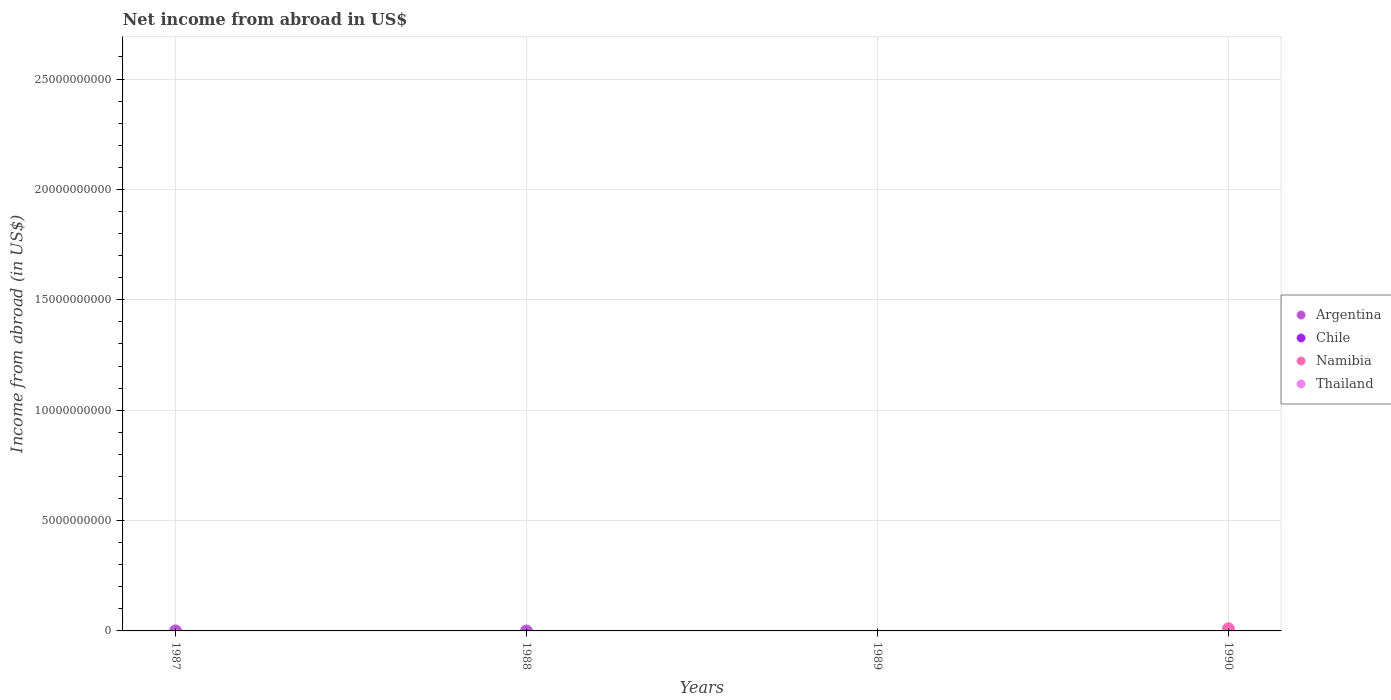Is the number of dotlines equal to the number of legend labels?
Make the answer very short. No. Across all years, what is the maximum net income from abroad in Namibia?
Make the answer very short. 9.70e+07. What is the total net income from abroad in Namibia in the graph?
Make the answer very short. 9.70e+07. Is it the case that in every year, the sum of the net income from abroad in Argentina and net income from abroad in Namibia  is greater than the net income from abroad in Chile?
Your answer should be compact. No. How many dotlines are there?
Keep it short and to the point. 1. What is the difference between two consecutive major ticks on the Y-axis?
Your response must be concise. 5.00e+09. Are the values on the major ticks of Y-axis written in scientific E-notation?
Your response must be concise. No. Does the graph contain any zero values?
Offer a terse response. Yes. What is the title of the graph?
Your response must be concise. Net income from abroad in US$. Does "Central African Republic" appear as one of the legend labels in the graph?
Make the answer very short. No. What is the label or title of the Y-axis?
Ensure brevity in your answer.  Income from abroad (in US$). What is the Income from abroad (in US$) of Chile in 1987?
Ensure brevity in your answer.  0. What is the Income from abroad (in US$) of Thailand in 1987?
Your answer should be very brief. 0. What is the Income from abroad (in US$) of Chile in 1988?
Provide a short and direct response. 0. What is the Income from abroad (in US$) of Namibia in 1988?
Ensure brevity in your answer.  0. What is the Income from abroad (in US$) in Argentina in 1989?
Offer a terse response. 0. What is the Income from abroad (in US$) in Namibia in 1989?
Make the answer very short. 0. What is the Income from abroad (in US$) in Thailand in 1989?
Make the answer very short. 0. What is the Income from abroad (in US$) of Argentina in 1990?
Your response must be concise. 0. What is the Income from abroad (in US$) in Chile in 1990?
Your response must be concise. 0. What is the Income from abroad (in US$) in Namibia in 1990?
Give a very brief answer. 9.70e+07. Across all years, what is the maximum Income from abroad (in US$) of Namibia?
Keep it short and to the point. 9.70e+07. Across all years, what is the minimum Income from abroad (in US$) of Namibia?
Make the answer very short. 0. What is the total Income from abroad (in US$) of Argentina in the graph?
Provide a short and direct response. 0. What is the total Income from abroad (in US$) of Namibia in the graph?
Give a very brief answer. 9.70e+07. What is the total Income from abroad (in US$) of Thailand in the graph?
Give a very brief answer. 0. What is the average Income from abroad (in US$) in Argentina per year?
Keep it short and to the point. 0. What is the average Income from abroad (in US$) in Namibia per year?
Provide a short and direct response. 2.43e+07. What is the difference between the highest and the lowest Income from abroad (in US$) of Namibia?
Ensure brevity in your answer.  9.70e+07. 